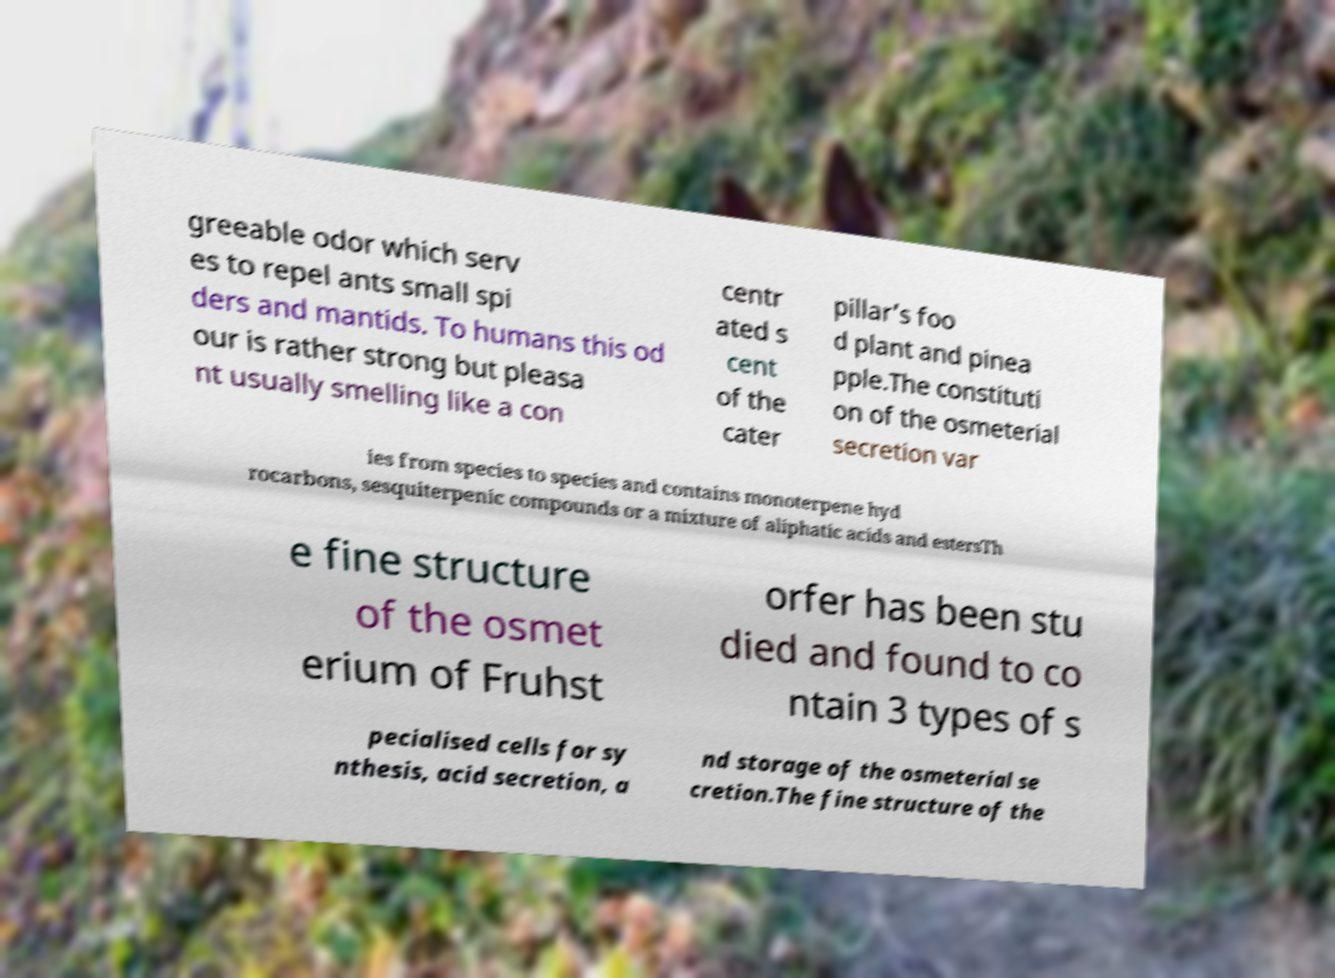Could you assist in decoding the text presented in this image and type it out clearly? greeable odor which serv es to repel ants small spi ders and mantids. To humans this od our is rather strong but pleasa nt usually smelling like a con centr ated s cent of the cater pillar’s foo d plant and pinea pple.The constituti on of the osmeterial secretion var ies from species to species and contains monoterpene hyd rocarbons, sesquiterpenic compounds or a mixture of aliphatic acids and estersTh e fine structure of the osmet erium of Fruhst orfer has been stu died and found to co ntain 3 types of s pecialised cells for sy nthesis, acid secretion, a nd storage of the osmeterial se cretion.The fine structure of the 